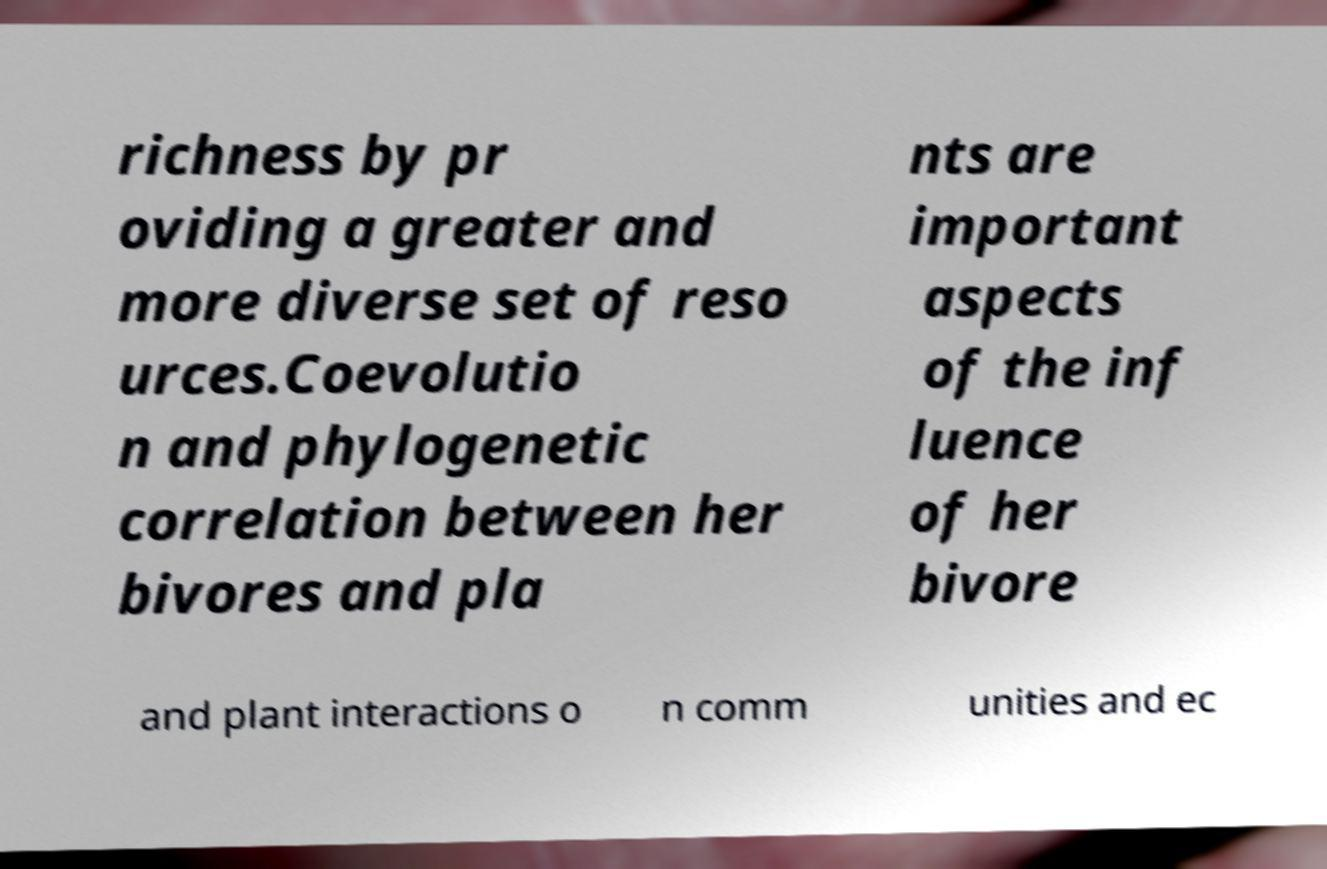Can you read and provide the text displayed in the image?This photo seems to have some interesting text. Can you extract and type it out for me? richness by pr oviding a greater and more diverse set of reso urces.Coevolutio n and phylogenetic correlation between her bivores and pla nts are important aspects of the inf luence of her bivore and plant interactions o n comm unities and ec 